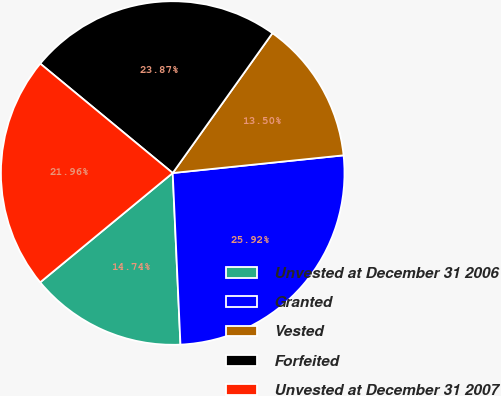Convert chart to OTSL. <chart><loc_0><loc_0><loc_500><loc_500><pie_chart><fcel>Unvested at December 31 2006<fcel>Granted<fcel>Vested<fcel>Forfeited<fcel>Unvested at December 31 2007<nl><fcel>14.74%<fcel>25.92%<fcel>13.5%<fcel>23.87%<fcel>21.96%<nl></chart> 